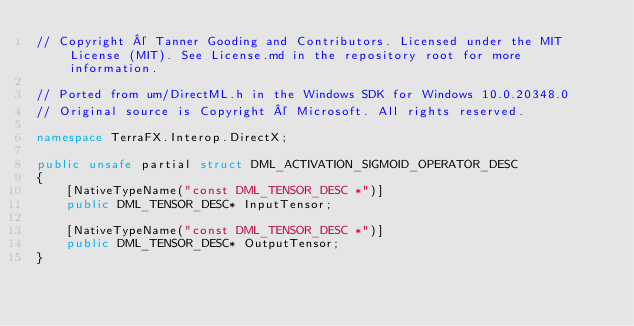<code> <loc_0><loc_0><loc_500><loc_500><_C#_>// Copyright © Tanner Gooding and Contributors. Licensed under the MIT License (MIT). See License.md in the repository root for more information.

// Ported from um/DirectML.h in the Windows SDK for Windows 10.0.20348.0
// Original source is Copyright © Microsoft. All rights reserved.

namespace TerraFX.Interop.DirectX;

public unsafe partial struct DML_ACTIVATION_SIGMOID_OPERATOR_DESC
{
    [NativeTypeName("const DML_TENSOR_DESC *")]
    public DML_TENSOR_DESC* InputTensor;

    [NativeTypeName("const DML_TENSOR_DESC *")]
    public DML_TENSOR_DESC* OutputTensor;
}
</code> 